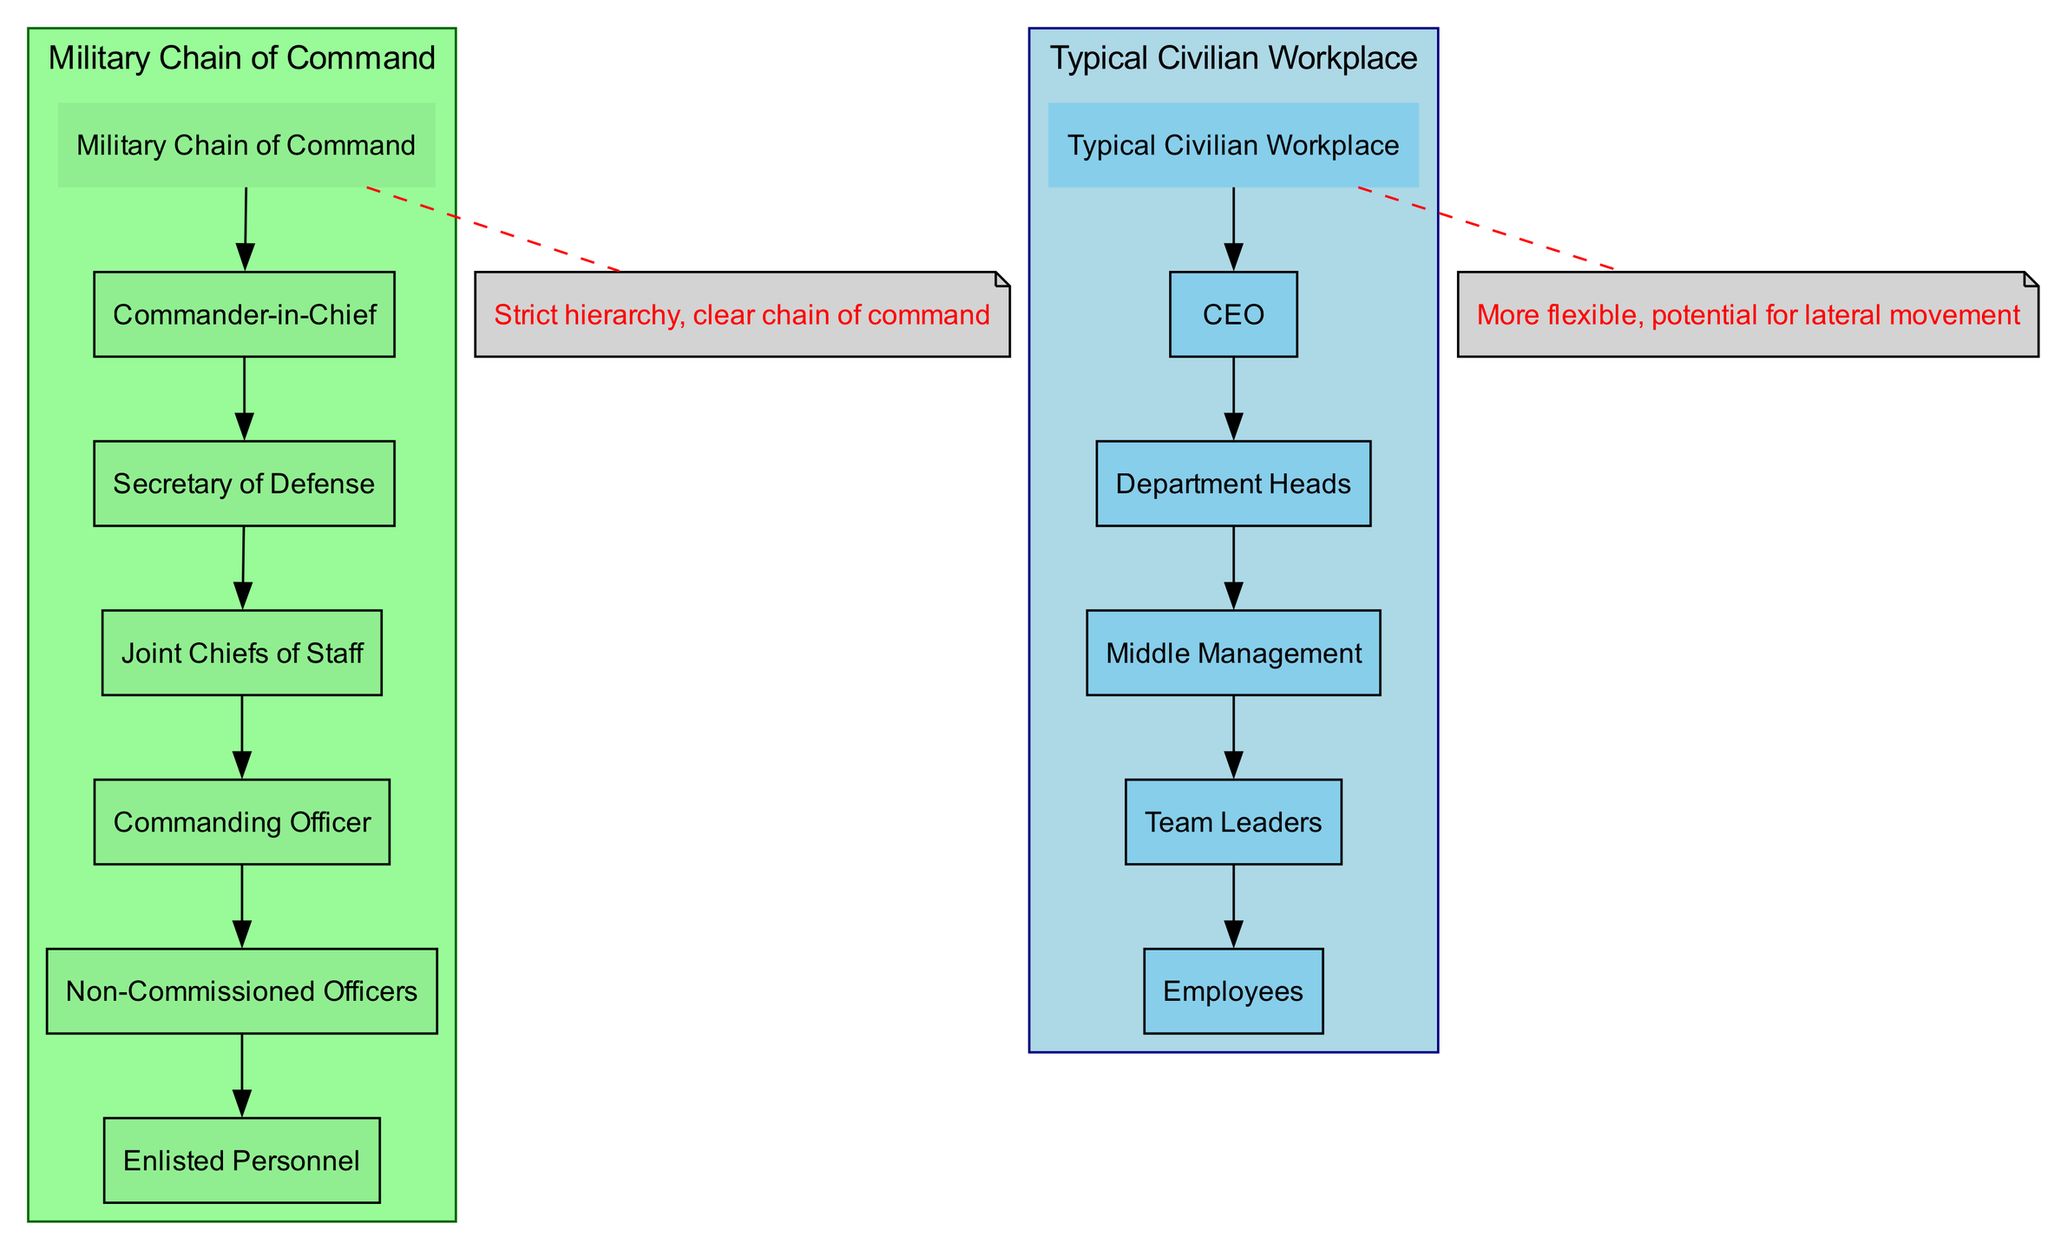what is the highest position in the military chain of command? The diagram indicates that the highest position is marked as "Commander-in-Chief." There is a direct connection from the "Military Chain of Command" node to the "Commander-in-Chief," showing it as the starting point of the hierarchy.
Answer: Commander-in-Chief how many nodes are in the civilian workplace hierarchy? The civilian workplace has five nodes labeled as CEO, Department Heads, Middle Management, Team Leaders, and Employees. Counting these nodes provides a total of five.
Answer: 5 what are the roles that fall under Non-Commissioned Officers? The diagram shows that "Non-Commissioned Officers" leads directly to "Enlisted Personnel," indicating that "Enlisted Personnel" are the roles that fall under it. Therefore, the role that falls under "Non-Commissioned Officers" is "Enlisted Personnel."
Answer: Enlisted Personnel what is the main difference in flexibility between military and civilian structures? The diagram includes annotations that specifically state that the military structure has a "strict hierarchy" while the civilian structure has "more flexible, potential for lateral movement." This captures the essential difference in flexibility between the two structures.
Answer: More flexible, potential for lateral movement how many levels are in the military structure compared to the civilian structure? The military structure includes six levels: Commander-in-Chief, Secretary of Defense, Joint Chiefs of Staff, Commanding Officer, Non-Commissioned Officers, and Enlisted Personnel. The civilian structure includes five levels: CEO, Department Heads, Middle Management, Team Leaders, and Employees. Comparing both structures gives us six levels for military and five for civilian.
Answer: Military: 6, Civilian: 5 which role is directly below the Joint Chiefs of Staff in the military chain of command? The diagram clearly shows an edge leading from "Joint Chiefs of Staff" to "Commanding Officer." This means that "Commanding Officer" is directly below the "Joint Chiefs of Staff" in the hierarchy.
Answer: Commanding Officer who is the top position in the civilian workplace structure? According to the diagram, the top position in the civilian workplace structure is represented as "CEO." It is the first role connected to the "Typical Civilian Workplace" node, establishing it as the top level.
Answer: CEO what positions are connected to Department Heads in the civilian structure? The diagram shows an edge from "Department Heads" to "Middle Management." It implies that "Middle Management" is directly connected to and below "Department Heads" within the civilian structure.
Answer: Middle Management how does the number of edges compare between the military and civilian sections? In the military section, there are five edges connecting the nodes from "Commander-in-Chief" down to "Enlisted Personnel." In the civilian section, there are four edges connecting the nodes from "CEO" to "Employees." Therefore, the military has more edges than the civilian section, indicating a more extensive hierarchical connection.
Answer: Military: 5, Civilian: 4 